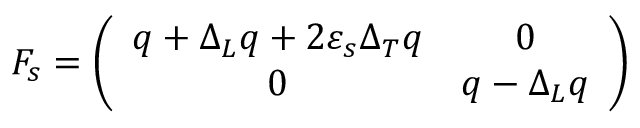Convert formula to latex. <formula><loc_0><loc_0><loc_500><loc_500>F _ { s } = \left ( \begin{array} { c c } { { q + \Delta _ { L } q + 2 \varepsilon _ { s } \Delta _ { T } q } } & { 0 } \\ { 0 } & { { q - \Delta _ { L } q } } \end{array} \right )</formula> 